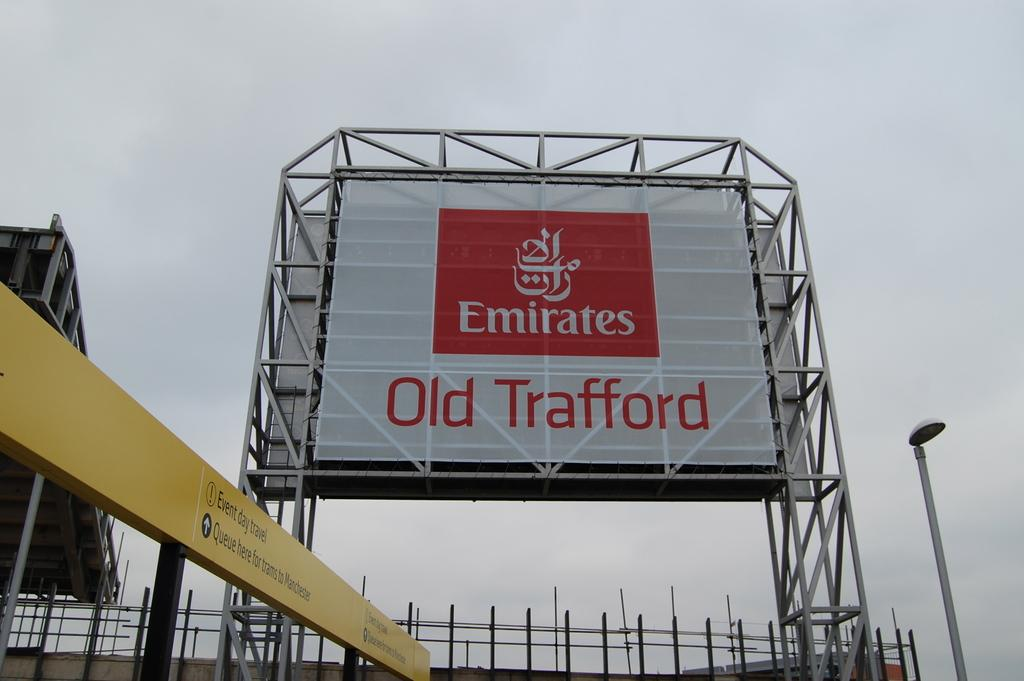<image>
Give a short and clear explanation of the subsequent image. The billboard has the words Emirates written on it. 